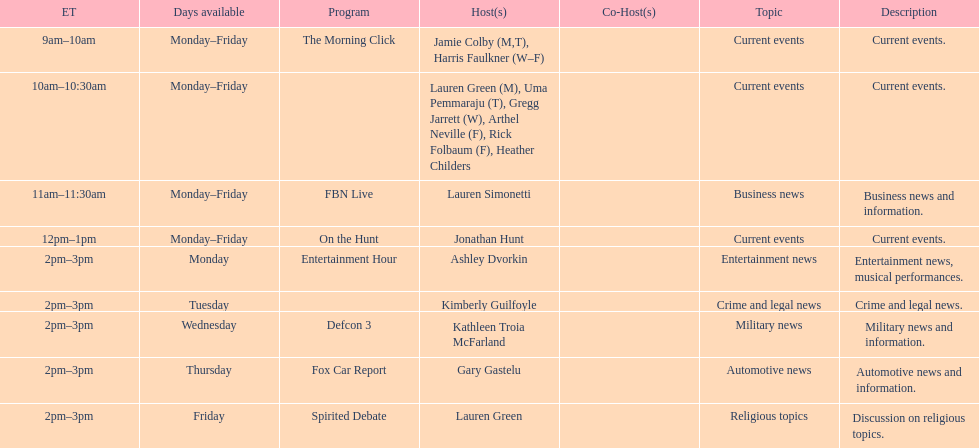Which program is only available on thursdays? Fox Car Report. 